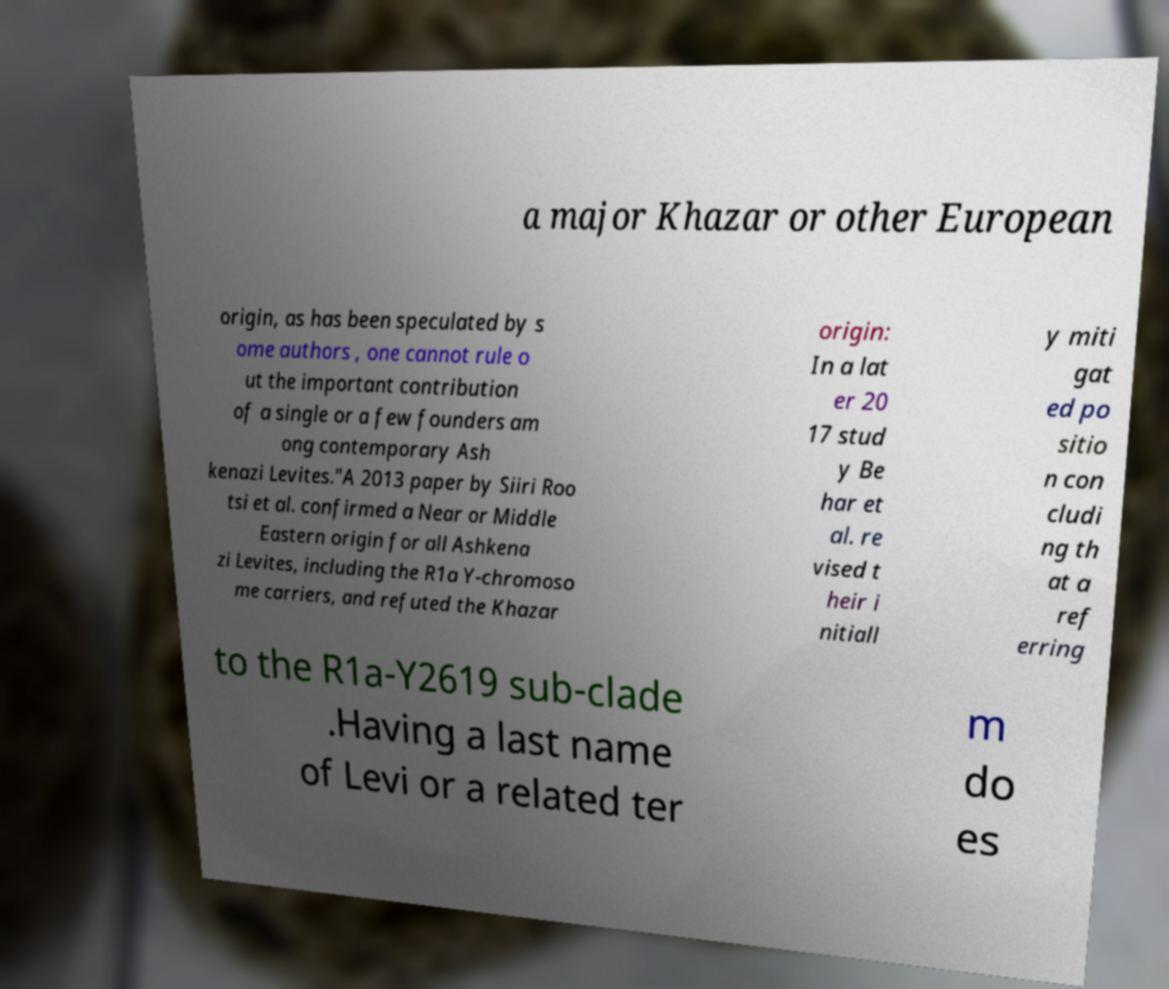Can you read and provide the text displayed in the image?This photo seems to have some interesting text. Can you extract and type it out for me? a major Khazar or other European origin, as has been speculated by s ome authors , one cannot rule o ut the important contribution of a single or a few founders am ong contemporary Ash kenazi Levites."A 2013 paper by Siiri Roo tsi et al. confirmed a Near or Middle Eastern origin for all Ashkena zi Levites, including the R1a Y-chromoso me carriers, and refuted the Khazar origin: In a lat er 20 17 stud y Be har et al. re vised t heir i nitiall y miti gat ed po sitio n con cludi ng th at a ref erring to the R1a-Y2619 sub-clade .Having a last name of Levi or a related ter m do es 